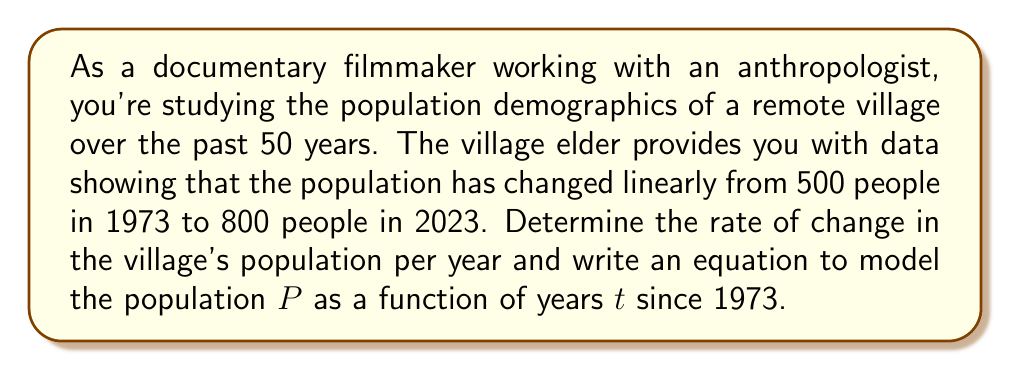Teach me how to tackle this problem. To solve this problem, we'll use the point-slope form of a linear equation:

$$y - y_1 = m(x - x_1)$$

Where $m$ is the slope (rate of change), and $(x_1, y_1)$ is a known point.

1. Calculate the rate of change (slope):
   $$m = \frac{y_2 - y_1}{x_2 - x_1} = \frac{800 - 500}{50 - 0} = \frac{300}{50} = 6$$

   The population is increasing by 6 people per year.

2. Use the point-slope form with the point (0, 500) and slope 6:
   $$P - 500 = 6(t - 0)$$

3. Simplify the equation:
   $$P = 6t + 500$$

This equation models the population $P$ as a function of years $t$ since 1973.
Answer: The rate of change in the village's population is 6 people per year. The equation modeling the population $P$ as a function of years $t$ since 1973 is $P = 6t + 500$. 